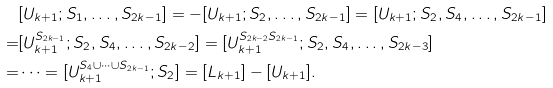Convert formula to latex. <formula><loc_0><loc_0><loc_500><loc_500>& [ U _ { k + 1 } ; S _ { 1 } , \dots , S _ { 2 k - 1 } ] = - [ U _ { k + 1 } ; S _ { 2 } , \dots , S _ { 2 k - 1 } ] = [ U _ { k + 1 } ; S _ { 2 } , S _ { 4 } , \dots , S _ { 2 k - 1 } ] \\ = & [ U _ { k + 1 } ^ { S _ { 2 k - 1 } } ; S _ { 2 } , S _ { 4 } , \dots , S _ { 2 k - 2 } ] = [ U _ { k + 1 } ^ { S _ { 2 k - 2 } S _ { 2 k - 1 } } ; S _ { 2 } , S _ { 4 } , \dots , S _ { 2 k - 3 } ] \\ = & \dots = [ U _ { k + 1 } ^ { S _ { 4 } \cup \cdots \cup S _ { 2 k - 1 } } ; S _ { 2 } ] = [ L _ { k + 1 } ] - [ U _ { k + 1 } ] .</formula> 